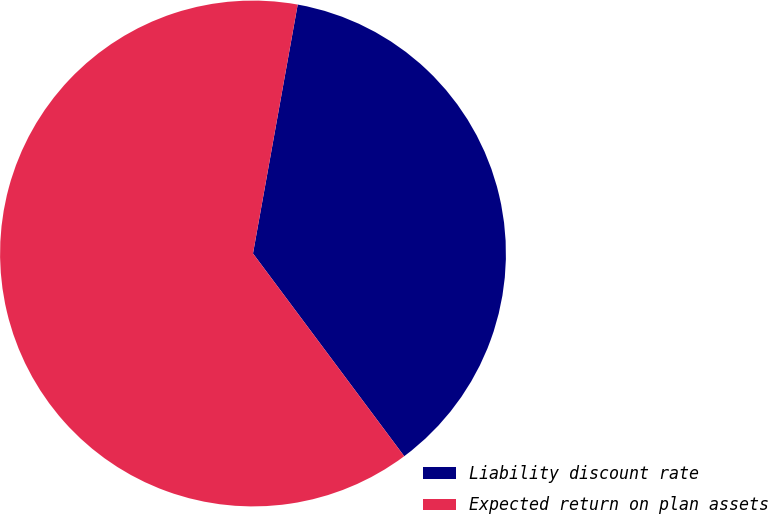Convert chart. <chart><loc_0><loc_0><loc_500><loc_500><pie_chart><fcel>Liability discount rate<fcel>Expected return on plan assets<nl><fcel>36.97%<fcel>63.03%<nl></chart> 